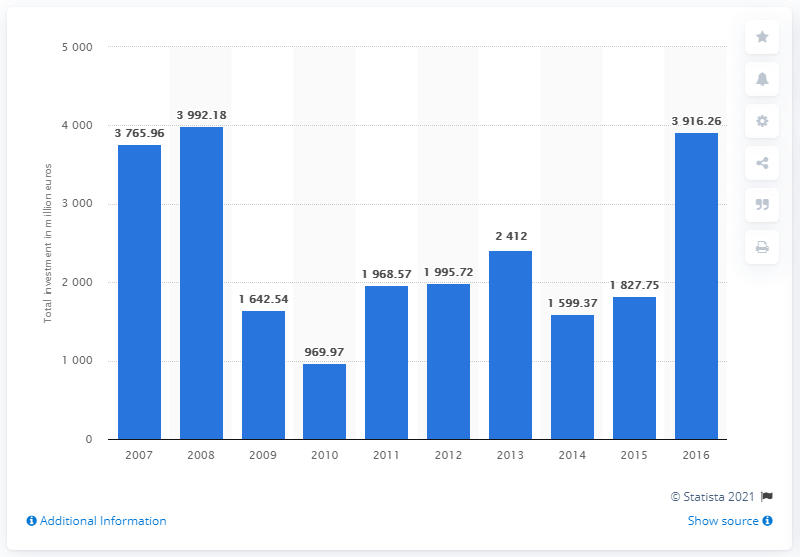Give some essential details in this illustration. The largest total value of private equity investments was found in 2008. Private equity investments in 2016 were valued at 3916.26. 